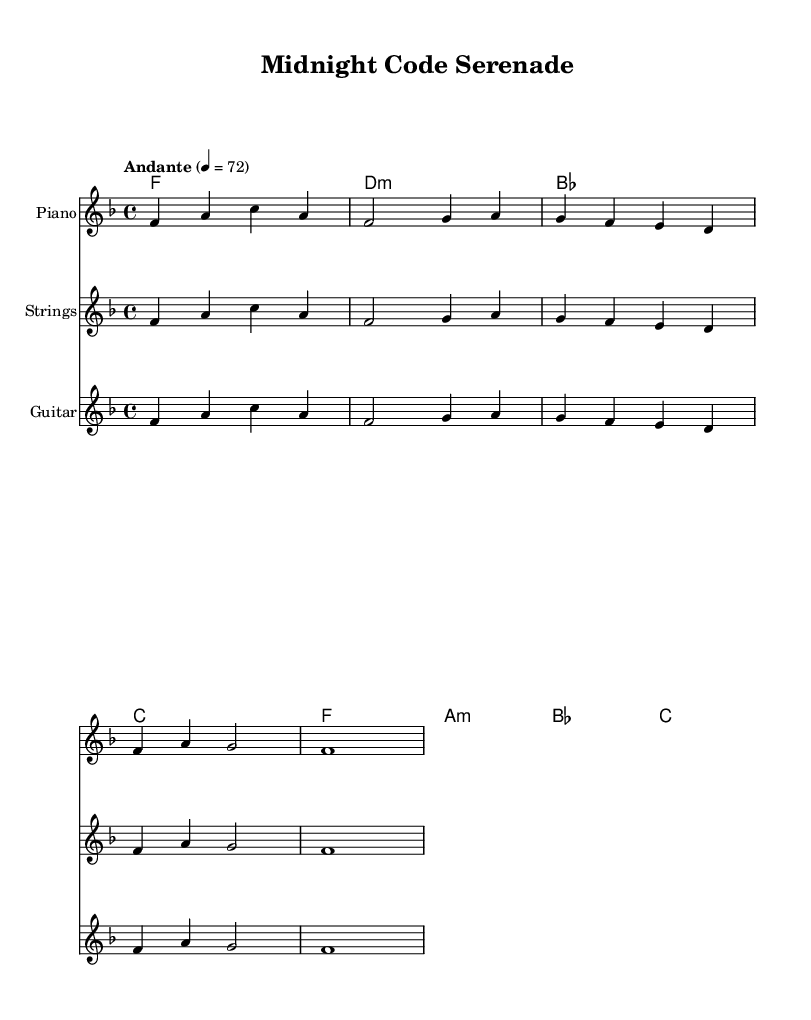What is the key signature of this music? The key signature is F major, which has one flat (B flat). This can be determined by looking at the key signature indicated at the beginning of the score.
Answer: F major What is the time signature of the piece? The time signature is 4/4, as indicated at the beginning of the score. This means there are four beats in each measure, and the quarter note gets one beat.
Answer: 4/4 What is the tempo marking for this piece? The tempo marking is "Andante" at a tempo of 72 beats per minute, which indicates a moderate pace. This information is found in the tempo indication following the global musical context at the start of the score.
Answer: Andante 4 = 72 How many measures are there in the melody? There are 8 measures in the melody, which can be counted by examining the end of each measure in the melody section of the score.
Answer: 8 What is the first chord played in the harmonies? The first chord is F major, as evident from the chord notations starting at the beginning of the harmonies section.
Answer: F major How many instruments are used in the score? There are three instruments used in the score: Piano, Strings, and Guitar. This can be verified from the instrument names listed in the staff headings of the score.
Answer: Three What type of harmony is used in the second measure? The harmony in the second measure is G minor, indicated by the notation "g" followed by "f" and the existing G in the chord progression, which confirms the minor quality.
Answer: G minor 